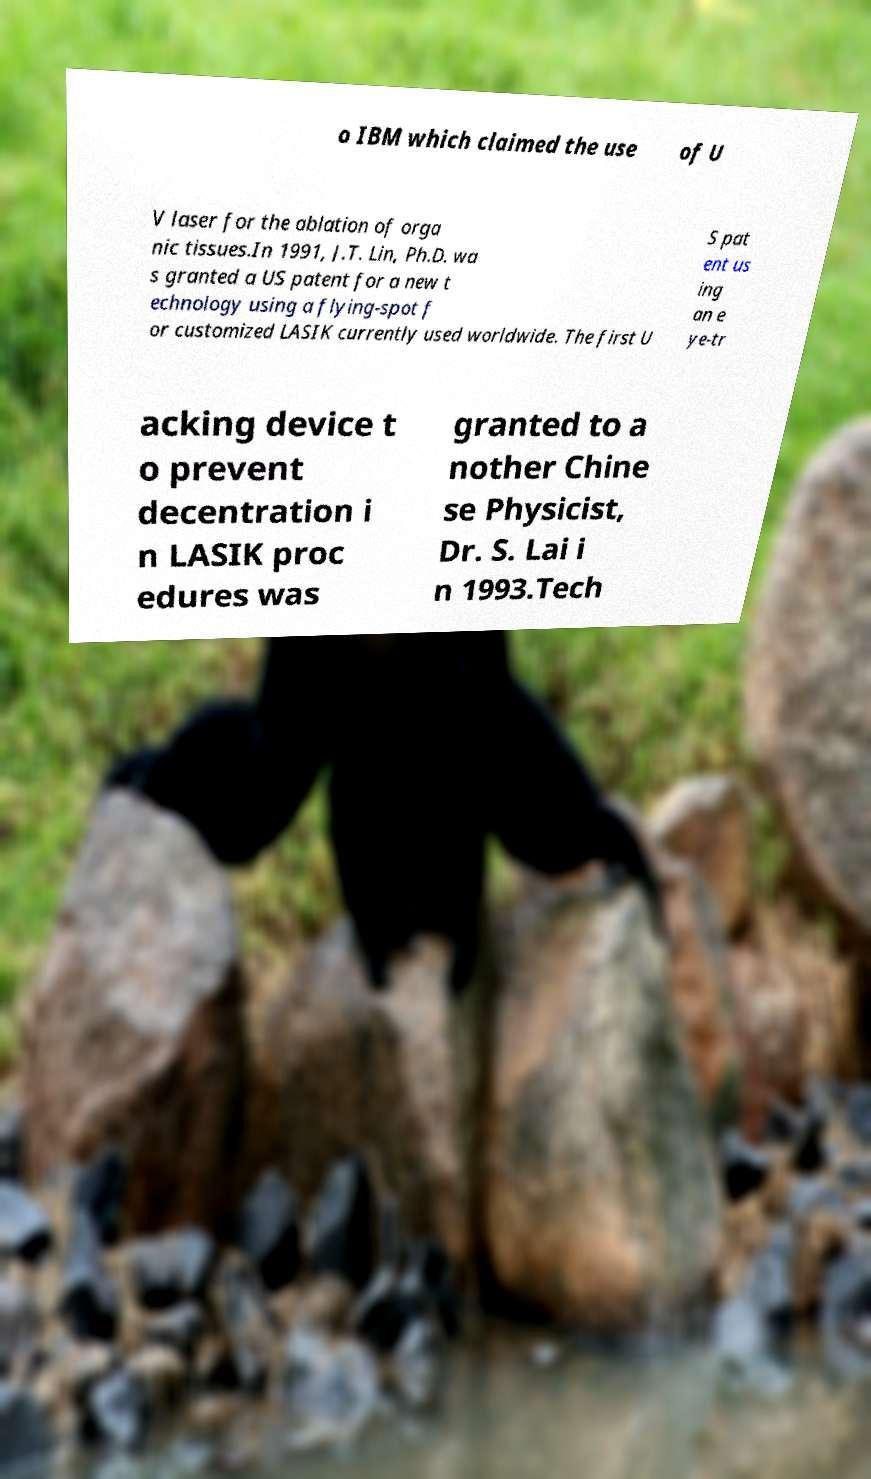Can you read and provide the text displayed in the image?This photo seems to have some interesting text. Can you extract and type it out for me? o IBM which claimed the use of U V laser for the ablation of orga nic tissues.In 1991, J.T. Lin, Ph.D. wa s granted a US patent for a new t echnology using a flying-spot f or customized LASIK currently used worldwide. The first U S pat ent us ing an e ye-tr acking device t o prevent decentration i n LASIK proc edures was granted to a nother Chine se Physicist, Dr. S. Lai i n 1993.Tech 